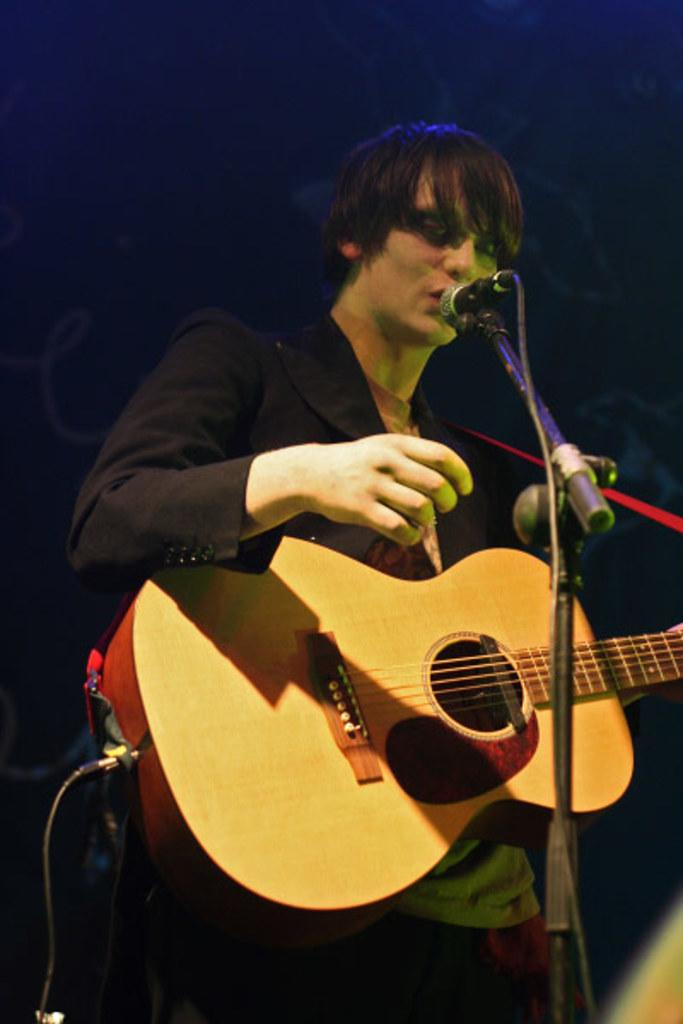What is the man in the image doing? The man is playing a guitar and singing. What is the man wearing in the image? The man is wearing a black suit. What instrument is the man using in the image? The man is using a microphone. What type of eggnog can be seen in the man's hand in the image? There is no eggnog present in the image; the man is holding a microphone. 